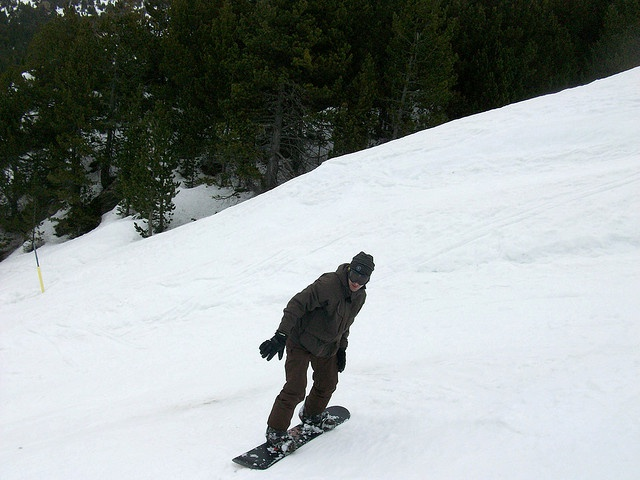Describe the objects in this image and their specific colors. I can see people in black, gray, white, and darkgray tones and snowboard in black, gray, lightgray, and darkgray tones in this image. 